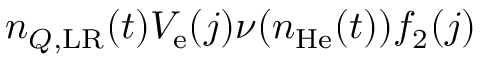<formula> <loc_0><loc_0><loc_500><loc_500>n _ { Q , L R } ( t ) V _ { e } ( j ) \nu ( n _ { H e } ( t ) ) f _ { 2 } ( j )</formula> 